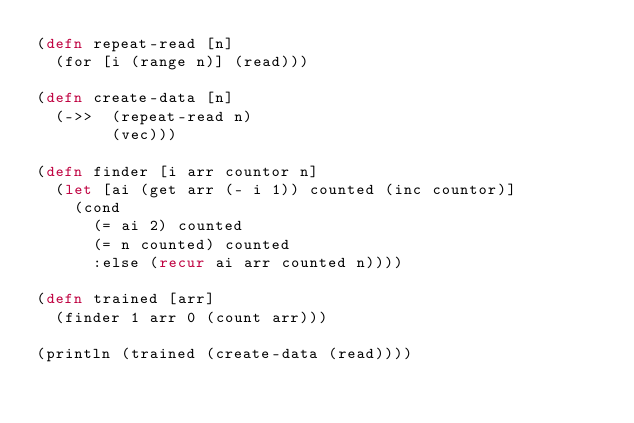Convert code to text. <code><loc_0><loc_0><loc_500><loc_500><_Clojure_>(defn repeat-read [n]
  (for [i (range n)] (read)))

(defn create-data [n]
  (->>  (repeat-read n)
        (vec)))

(defn finder [i arr countor n]
  (let [ai (get arr (- i 1)) counted (inc countor)]
    (cond
      (= ai 2) counted
      (= n counted) counted
      :else (recur ai arr counted n))))

(defn trained [arr]
  (finder 1 arr 0 (count arr)))

(println (trained (create-data (read))))</code> 